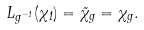<formula> <loc_0><loc_0><loc_500><loc_500>L _ { g ^ { - 1 } } ( \chi _ { 1 } ) = \tilde { \chi } _ { g } = \chi _ { g } .</formula> 